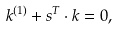<formula> <loc_0><loc_0><loc_500><loc_500>k ^ { ( 1 ) } + { s ^ { T } } \cdot { k } = 0 ,</formula> 